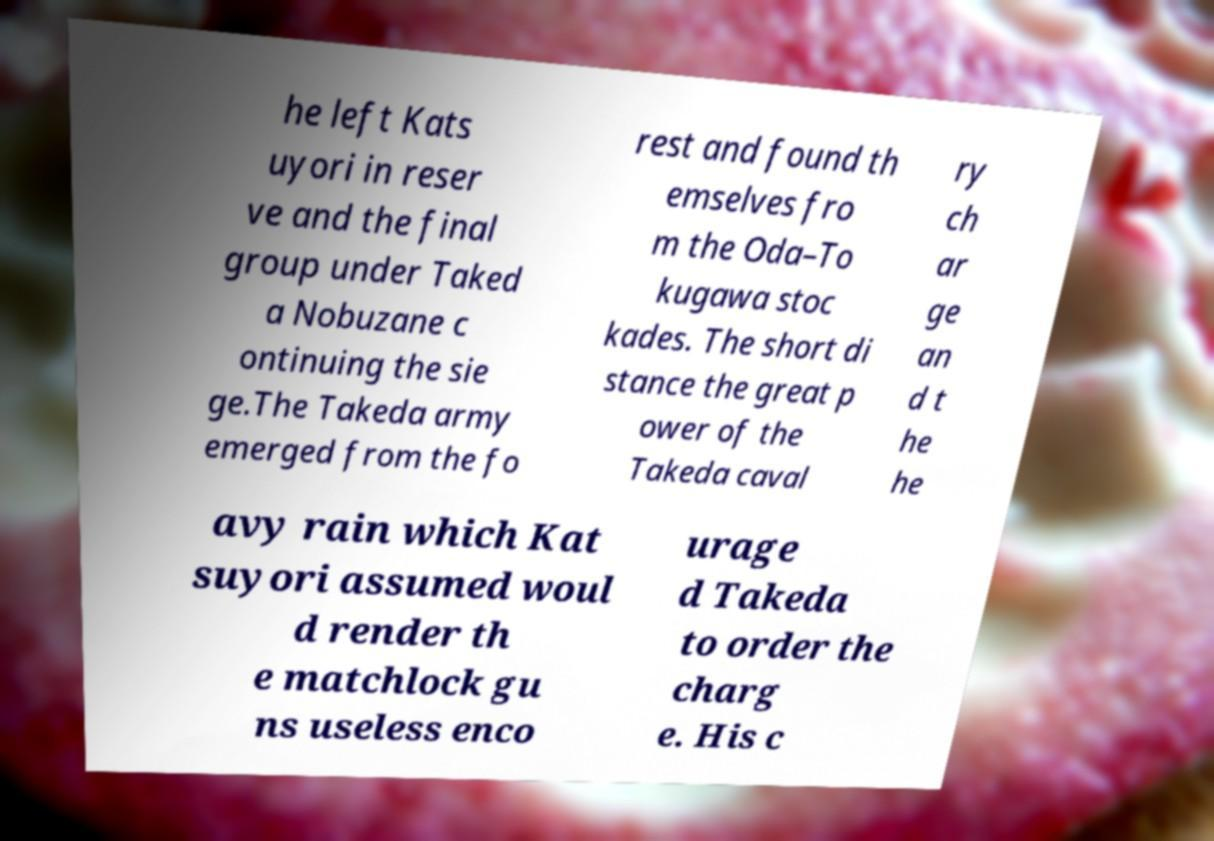I need the written content from this picture converted into text. Can you do that? he left Kats uyori in reser ve and the final group under Taked a Nobuzane c ontinuing the sie ge.The Takeda army emerged from the fo rest and found th emselves fro m the Oda–To kugawa stoc kades. The short di stance the great p ower of the Takeda caval ry ch ar ge an d t he he avy rain which Kat suyori assumed woul d render th e matchlock gu ns useless enco urage d Takeda to order the charg e. His c 